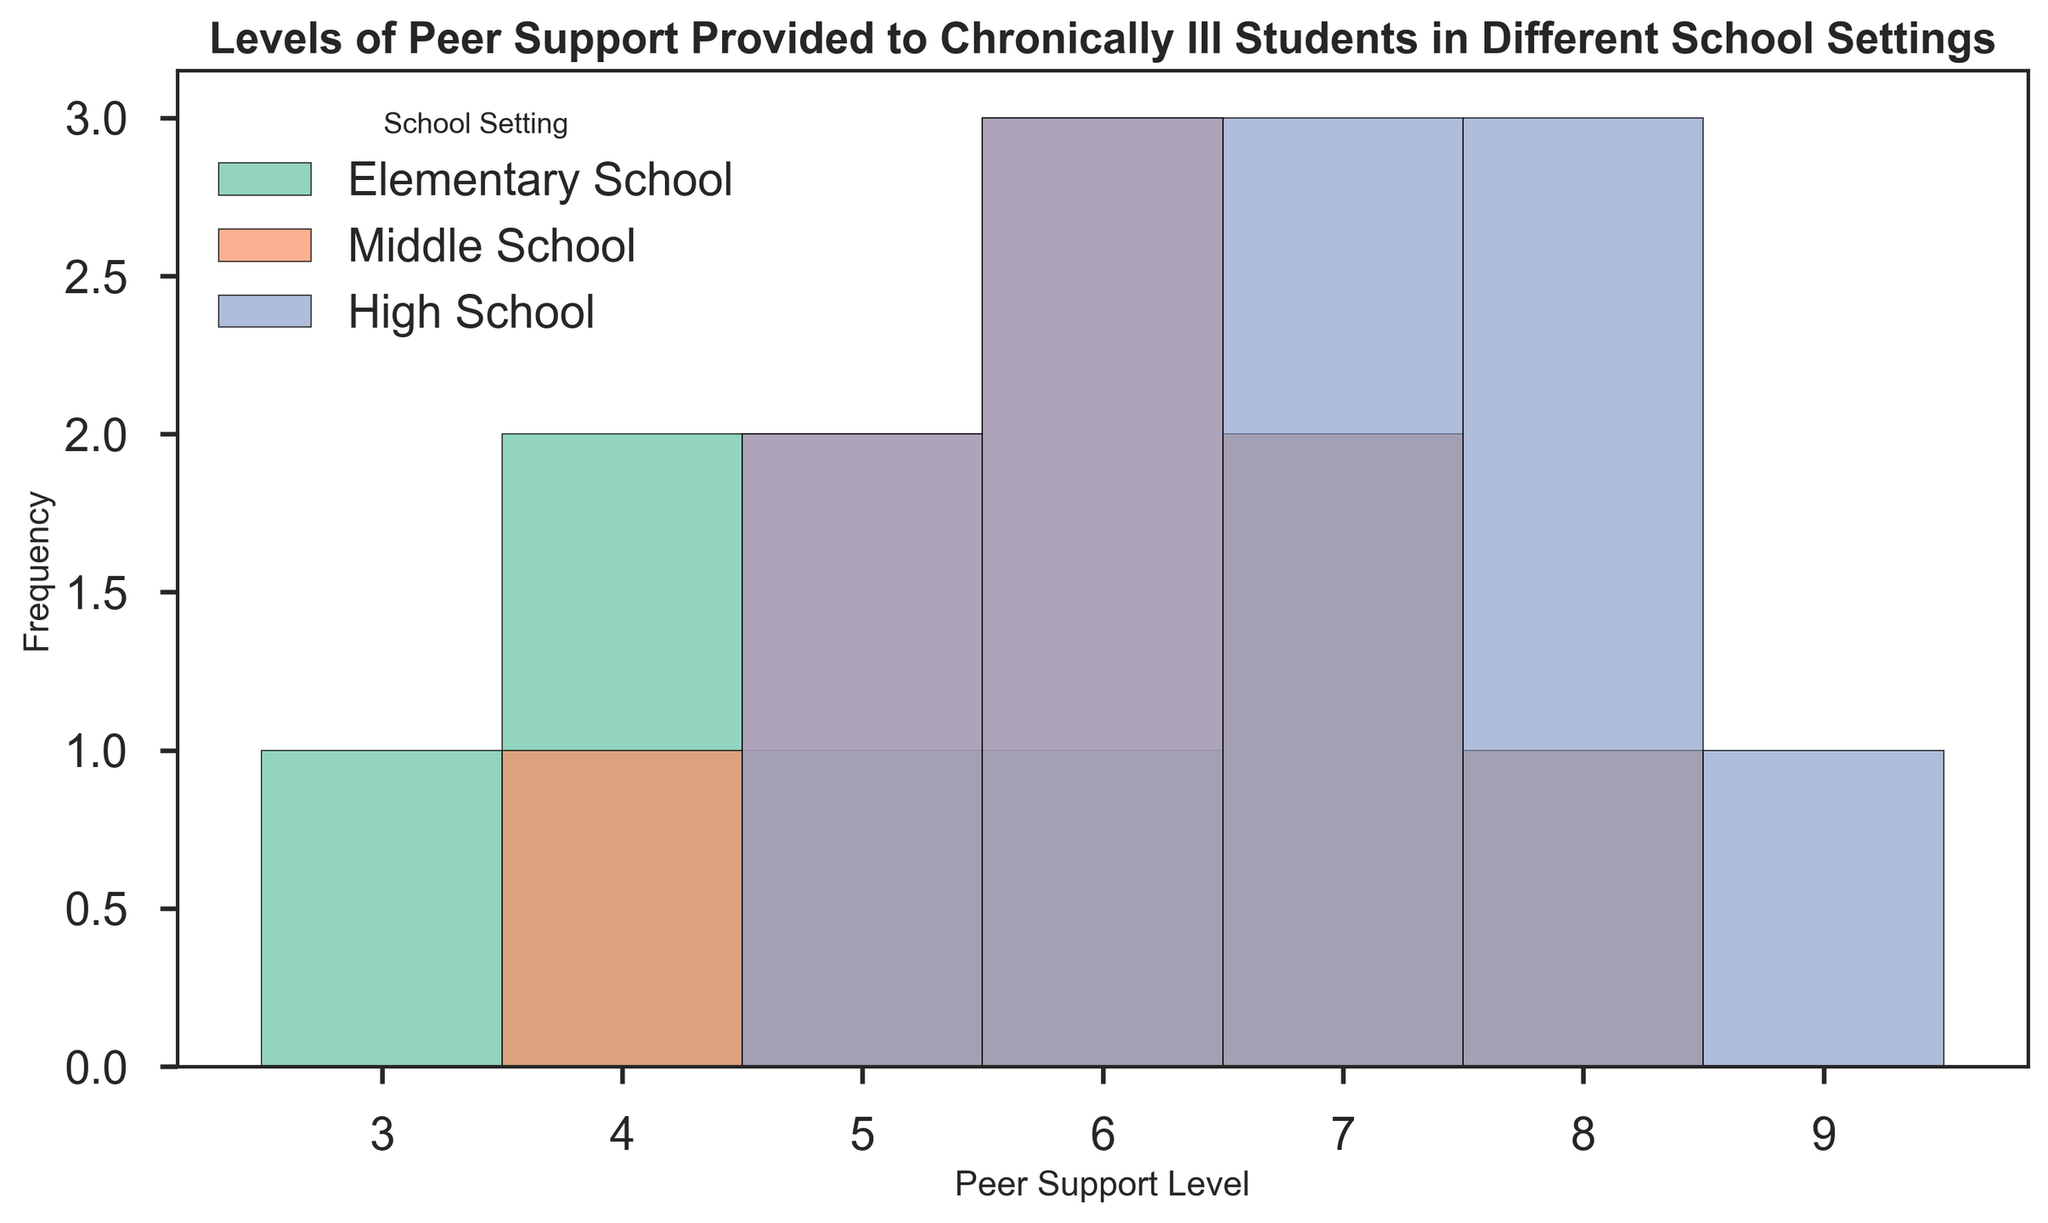How many school settings are represented in the figure? The figure includes a legend that shows each school setting represented with different colors. By counting the number of unique school settings in the legend, we find there are three: Elementary School, Middle School, and High School.
Answer: Three Which school setting has the highest frequency of Peer Support Level 7? By observing the height of the bars at Peer Support Level 7 across different school settings, we see that the bar for High School is the tallest, indicating the highest frequency.
Answer: High School What is the combined number of instances of Peer Support Level 6 and 7 in Middle School? Look at the bars for Peer Support Levels 6 and 7 in Middle School. Sum their frequencies: Level 6 has a frequency of 3, and Level 7 has a frequency of 3 as well. So, 3 + 3 = 6.
Answer: 6 Compare the frequency of Peer Support Level 5 between Elementary School and High School. Which one is higher? By observing the height of the bars for Peer Support Level 5 in both Elementary and High School, it's clear that they are equal, as both bars reach the same height.
Answer: Equal What is the most common Peer Support Level in Elementary School? Look for the tallest bar within the Elementary School data section. The tallest bar corresponds to Peer Support Level 7.
Answer: 7 Which Peer Support Level appears the most frequently across all three school settings combined? By comparing the highest peaks of the bars across all school settings combined, Peer Support Level 6 and 7 appear most frequently. Both have high frequencies in multiple settings, but Level 7 has the highest overall.
Answer: 7 What is the difference in frequency between Peer Support Level 5 in Middle School and High School? Look at the heights of the bars for Peer Support Level 5 in Middle School and High School. Middle School has a frequency of 2, and High School has a frequency of 3. The difference is 3 - 2 = 1.
Answer: 1 How many total instances of Peer Support Level 8 are there across all school settings? Sum the frequencies of the bars at Peer Support Level 8 across all school settings. Elementary School has 1, Middle School has 1, and High School has 3. So, 1 + 1 + 3 = 5.
Answer: 5 What is the range of Peer Support Levels observed in the figure? The minimum and maximum Peer Support Levels in the figure can be identified by looking at the bars from the lowest to the highest Peer Support Levels with non-zero frequency. They range from 3 to 9.
Answer: 3 to 9 